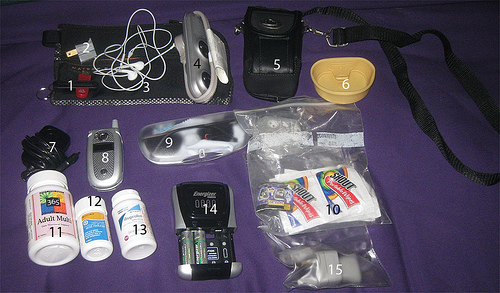Please transcribe the text information in this image. 14 13 12 11 9 8 7 Mu Adult 365 15 SHOUT 10 SHOUT SHOUT 6 5 4 3 2 1 